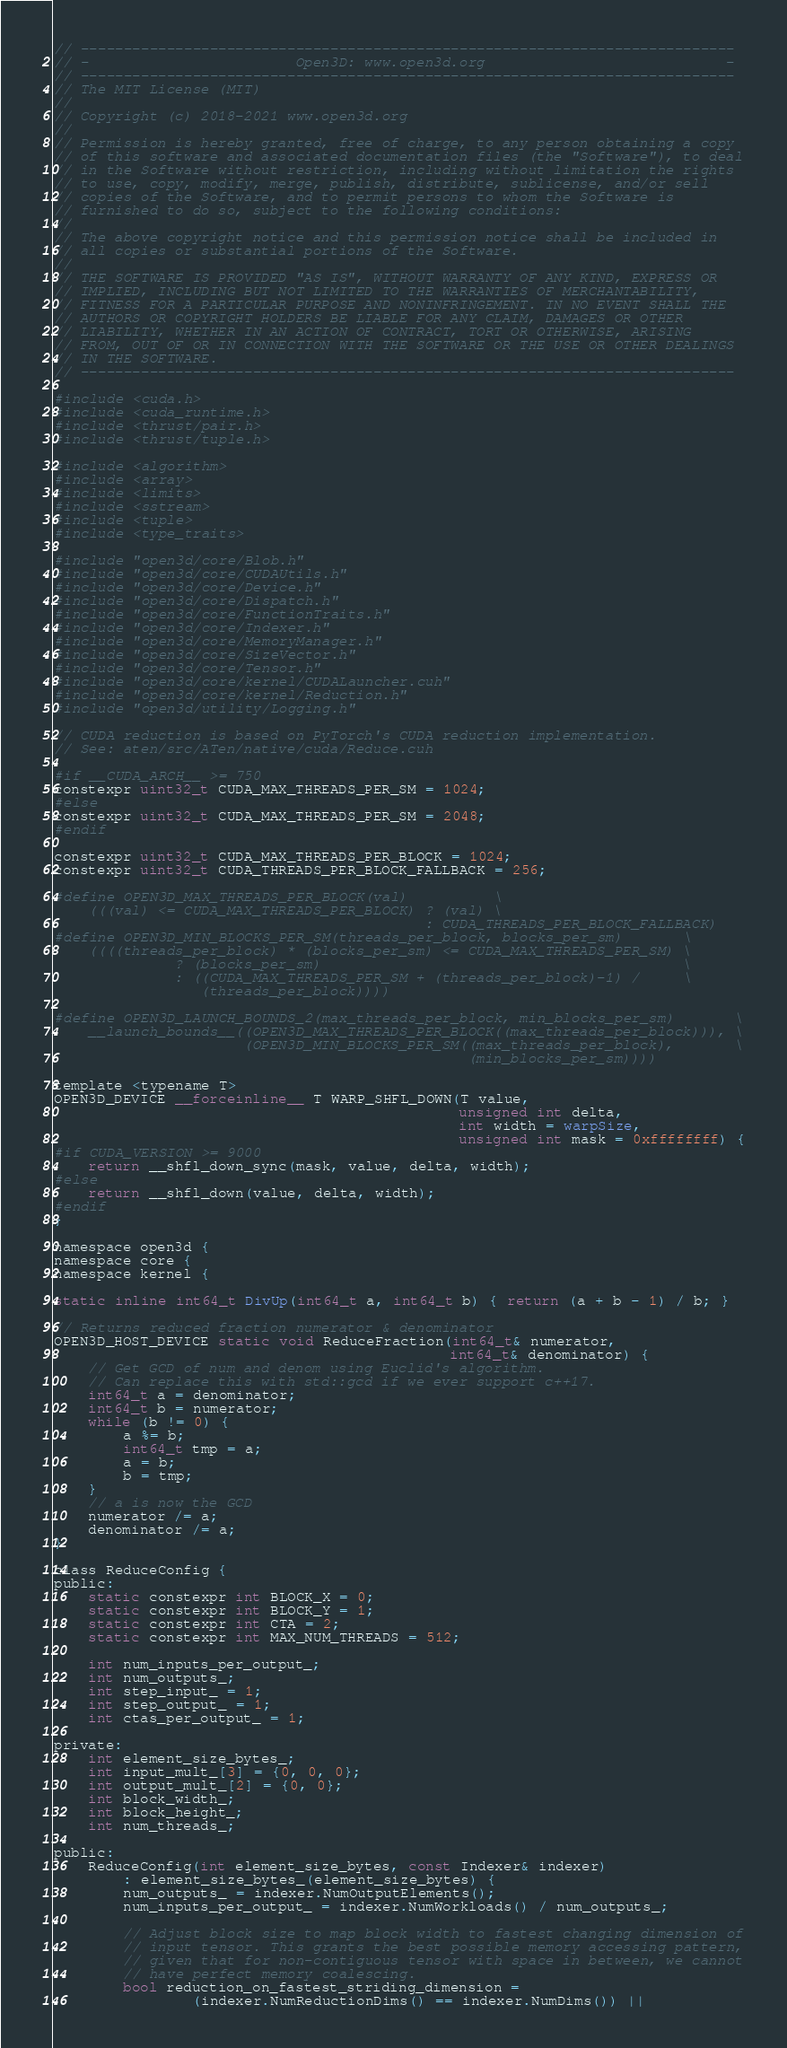<code> <loc_0><loc_0><loc_500><loc_500><_Cuda_>// ----------------------------------------------------------------------------
// -                        Open3D: www.open3d.org                            -
// ----------------------------------------------------------------------------
// The MIT License (MIT)
//
// Copyright (c) 2018-2021 www.open3d.org
//
// Permission is hereby granted, free of charge, to any person obtaining a copy
// of this software and associated documentation files (the "Software"), to deal
// in the Software without restriction, including without limitation the rights
// to use, copy, modify, merge, publish, distribute, sublicense, and/or sell
// copies of the Software, and to permit persons to whom the Software is
// furnished to do so, subject to the following conditions:
//
// The above copyright notice and this permission notice shall be included in
// all copies or substantial portions of the Software.
//
// THE SOFTWARE IS PROVIDED "AS IS", WITHOUT WARRANTY OF ANY KIND, EXPRESS OR
// IMPLIED, INCLUDING BUT NOT LIMITED TO THE WARRANTIES OF MERCHANTABILITY,
// FITNESS FOR A PARTICULAR PURPOSE AND NONINFRINGEMENT. IN NO EVENT SHALL THE
// AUTHORS OR COPYRIGHT HOLDERS BE LIABLE FOR ANY CLAIM, DAMAGES OR OTHER
// LIABILITY, WHETHER IN AN ACTION OF CONTRACT, TORT OR OTHERWISE, ARISING
// FROM, OUT OF OR IN CONNECTION WITH THE SOFTWARE OR THE USE OR OTHER DEALINGS
// IN THE SOFTWARE.
// ----------------------------------------------------------------------------

#include <cuda.h>
#include <cuda_runtime.h>
#include <thrust/pair.h>
#include <thrust/tuple.h>

#include <algorithm>
#include <array>
#include <limits>
#include <sstream>
#include <tuple>
#include <type_traits>

#include "open3d/core/Blob.h"
#include "open3d/core/CUDAUtils.h"
#include "open3d/core/Device.h"
#include "open3d/core/Dispatch.h"
#include "open3d/core/FunctionTraits.h"
#include "open3d/core/Indexer.h"
#include "open3d/core/MemoryManager.h"
#include "open3d/core/SizeVector.h"
#include "open3d/core/Tensor.h"
#include "open3d/core/kernel/CUDALauncher.cuh"
#include "open3d/core/kernel/Reduction.h"
#include "open3d/utility/Logging.h"

// CUDA reduction is based on PyTorch's CUDA reduction implementation.
// See: aten/src/ATen/native/cuda/Reduce.cuh

#if __CUDA_ARCH__ >= 750
constexpr uint32_t CUDA_MAX_THREADS_PER_SM = 1024;
#else
constexpr uint32_t CUDA_MAX_THREADS_PER_SM = 2048;
#endif

constexpr uint32_t CUDA_MAX_THREADS_PER_BLOCK = 1024;
constexpr uint32_t CUDA_THREADS_PER_BLOCK_FALLBACK = 256;

#define OPEN3D_MAX_THREADS_PER_BLOCK(val)          \
    (((val) <= CUDA_MAX_THREADS_PER_BLOCK) ? (val) \
                                           : CUDA_THREADS_PER_BLOCK_FALLBACK)
#define OPEN3D_MIN_BLOCKS_PER_SM(threads_per_block, blocks_per_sm)       \
    ((((threads_per_block) * (blocks_per_sm) <= CUDA_MAX_THREADS_PER_SM) \
              ? (blocks_per_sm)                                          \
              : ((CUDA_MAX_THREADS_PER_SM + (threads_per_block)-1) /     \
                 (threads_per_block))))

#define OPEN3D_LAUNCH_BOUNDS_2(max_threads_per_block, min_blocks_per_sm)       \
    __launch_bounds__((OPEN3D_MAX_THREADS_PER_BLOCK((max_threads_per_block))), \
                      (OPEN3D_MIN_BLOCKS_PER_SM((max_threads_per_block),       \
                                                (min_blocks_per_sm))))

template <typename T>
OPEN3D_DEVICE __forceinline__ T WARP_SHFL_DOWN(T value,
                                               unsigned int delta,
                                               int width = warpSize,
                                               unsigned int mask = 0xffffffff) {
#if CUDA_VERSION >= 9000
    return __shfl_down_sync(mask, value, delta, width);
#else
    return __shfl_down(value, delta, width);
#endif
}

namespace open3d {
namespace core {
namespace kernel {

static inline int64_t DivUp(int64_t a, int64_t b) { return (a + b - 1) / b; }

// Returns reduced fraction numerator & denominator
OPEN3D_HOST_DEVICE static void ReduceFraction(int64_t& numerator,
                                              int64_t& denominator) {
    // Get GCD of num and denom using Euclid's algorithm.
    // Can replace this with std::gcd if we ever support c++17.
    int64_t a = denominator;
    int64_t b = numerator;
    while (b != 0) {
        a %= b;
        int64_t tmp = a;
        a = b;
        b = tmp;
    }
    // a is now the GCD
    numerator /= a;
    denominator /= a;
}

class ReduceConfig {
public:
    static constexpr int BLOCK_X = 0;
    static constexpr int BLOCK_Y = 1;
    static constexpr int CTA = 2;
    static constexpr int MAX_NUM_THREADS = 512;

    int num_inputs_per_output_;
    int num_outputs_;
    int step_input_ = 1;
    int step_output_ = 1;
    int ctas_per_output_ = 1;

private:
    int element_size_bytes_;
    int input_mult_[3] = {0, 0, 0};
    int output_mult_[2] = {0, 0};
    int block_width_;
    int block_height_;
    int num_threads_;

public:
    ReduceConfig(int element_size_bytes, const Indexer& indexer)
        : element_size_bytes_(element_size_bytes) {
        num_outputs_ = indexer.NumOutputElements();
        num_inputs_per_output_ = indexer.NumWorkloads() / num_outputs_;

        // Adjust block size to map block width to fastest changing dimension of
        // input tensor. This grants the best possible memory accessing pattern,
        // given that for non-contiguous tensor with space in between, we cannot
        // have perfect memory coalescing.
        bool reduction_on_fastest_striding_dimension =
                (indexer.NumReductionDims() == indexer.NumDims()) ||</code> 